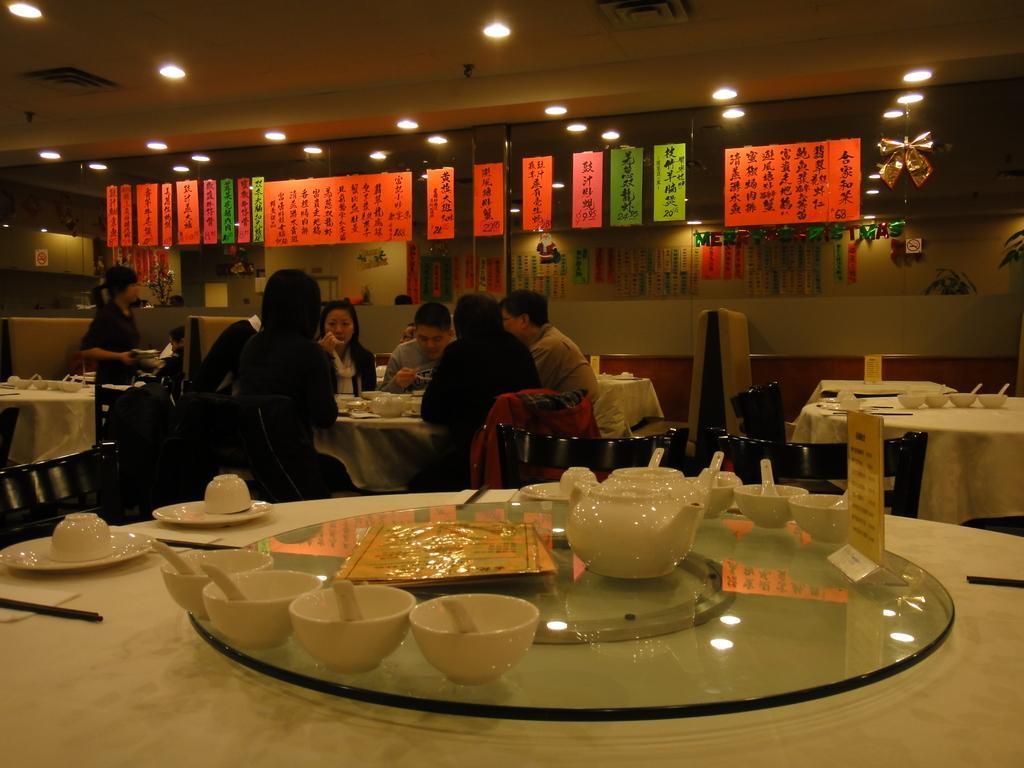Describe this image in one or two sentences. In this image, we can see so many tables and black color chairs. Glass item on the table. Bowl, spoon and the menu card on the table. In the middle of the image, Few peoples are sat on the chair. On the left side, a woman is standing. Back side, we can see Glass and some stickers and the roof, light. 